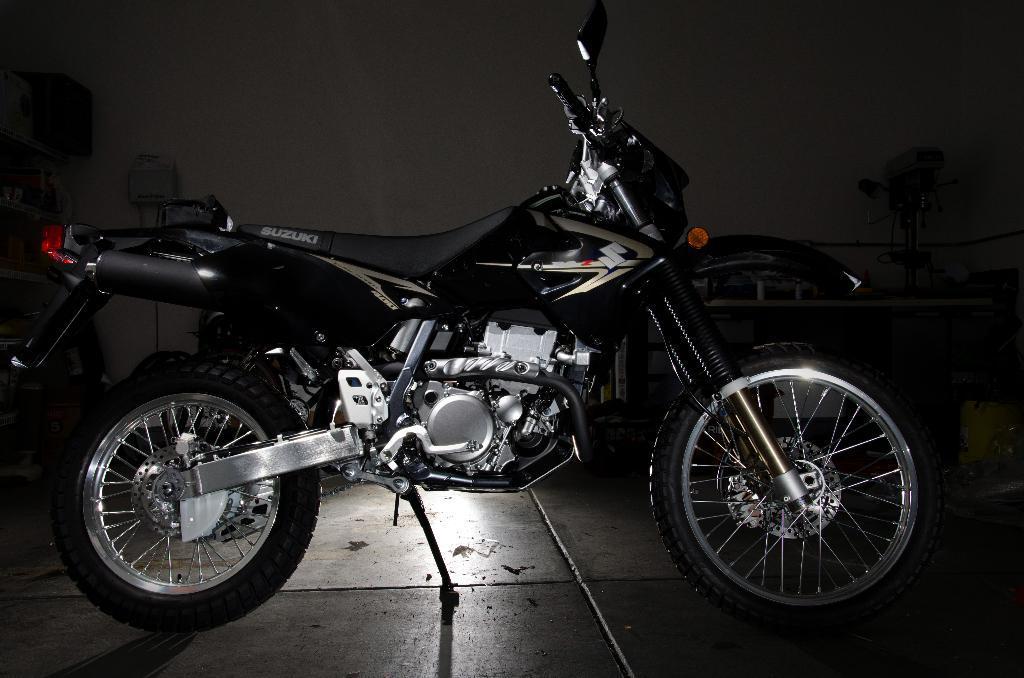Could you give a brief overview of what you see in this image? In the picture we can see a motorcycle parked on the path in the dark, the motorcycle is black in color and in the background, we can see wall with something placed beside it on the floor. 